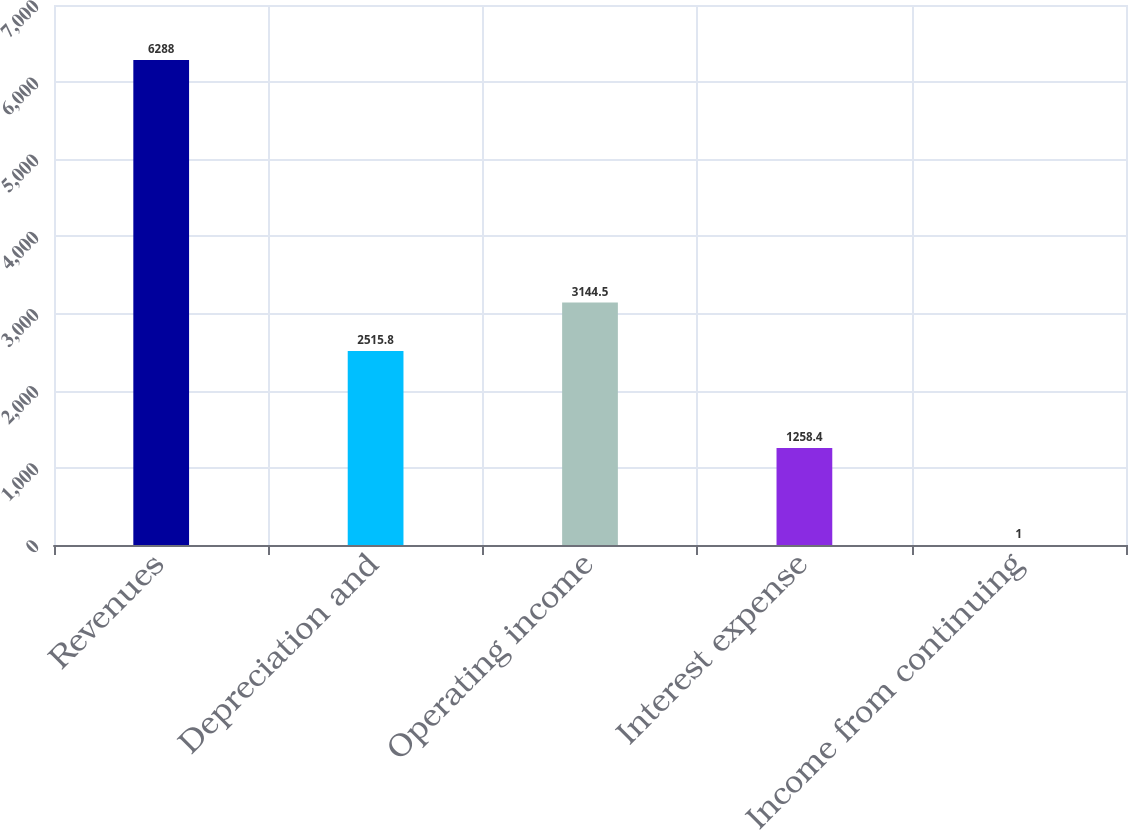Convert chart to OTSL. <chart><loc_0><loc_0><loc_500><loc_500><bar_chart><fcel>Revenues<fcel>Depreciation and<fcel>Operating income<fcel>Interest expense<fcel>Income from continuing<nl><fcel>6288<fcel>2515.8<fcel>3144.5<fcel>1258.4<fcel>1<nl></chart> 